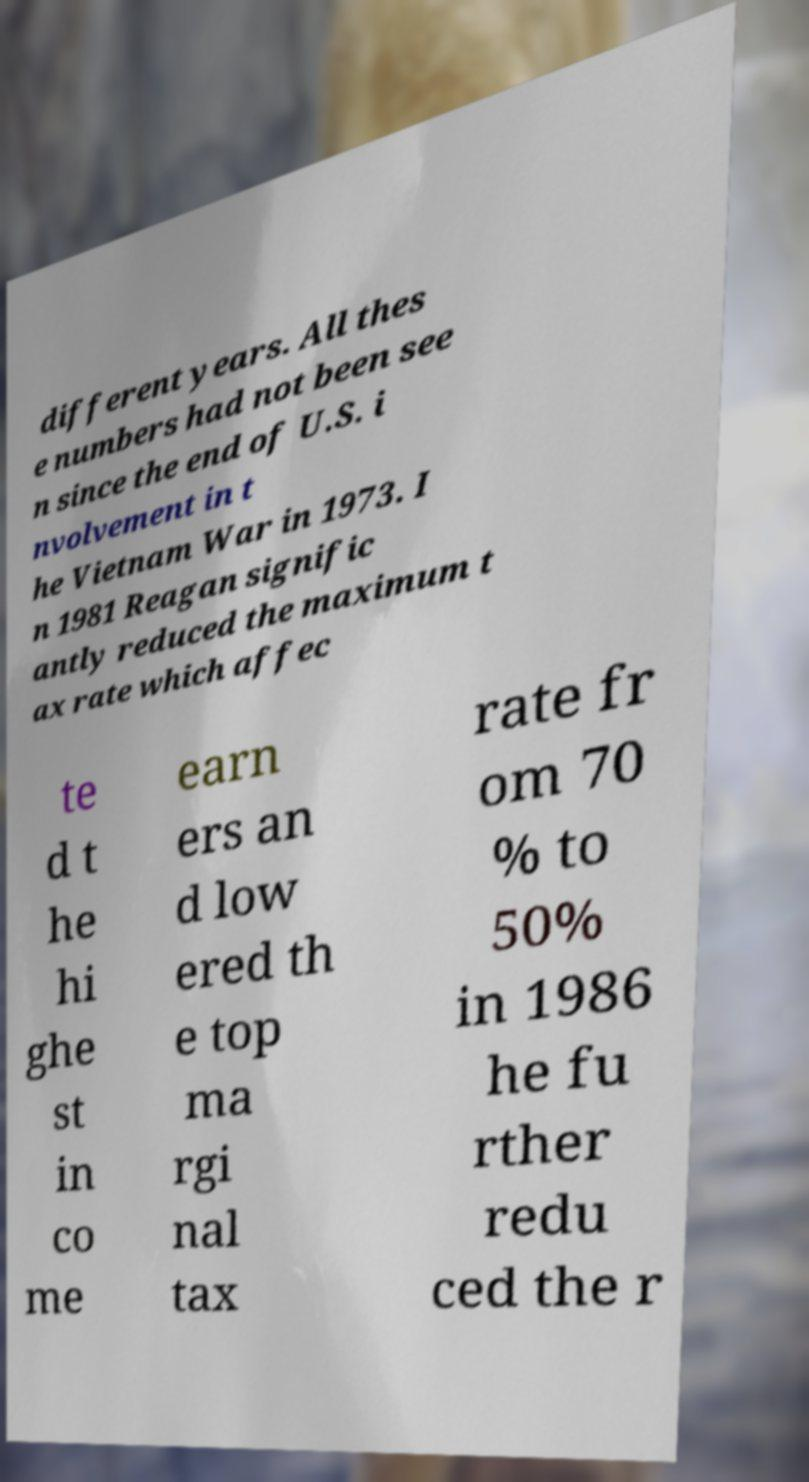There's text embedded in this image that I need extracted. Can you transcribe it verbatim? different years. All thes e numbers had not been see n since the end of U.S. i nvolvement in t he Vietnam War in 1973. I n 1981 Reagan signific antly reduced the maximum t ax rate which affec te d t he hi ghe st in co me earn ers an d low ered th e top ma rgi nal tax rate fr om 70 % to 50% in 1986 he fu rther redu ced the r 